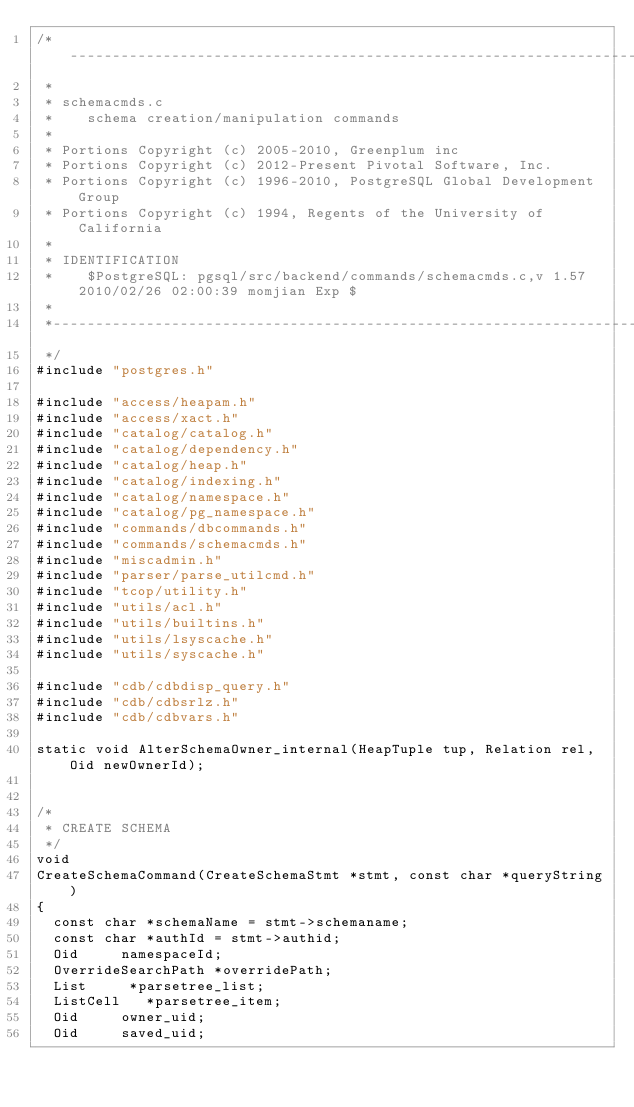Convert code to text. <code><loc_0><loc_0><loc_500><loc_500><_C_>/*-------------------------------------------------------------------------
 *
 * schemacmds.c
 *	  schema creation/manipulation commands
 *
 * Portions Copyright (c) 2005-2010, Greenplum inc
 * Portions Copyright (c) 2012-Present Pivotal Software, Inc.
 * Portions Copyright (c) 1996-2010, PostgreSQL Global Development Group
 * Portions Copyright (c) 1994, Regents of the University of California
 *
 * IDENTIFICATION
 *	  $PostgreSQL: pgsql/src/backend/commands/schemacmds.c,v 1.57 2010/02/26 02:00:39 momjian Exp $
 *
 *-------------------------------------------------------------------------
 */
#include "postgres.h"

#include "access/heapam.h"
#include "access/xact.h"
#include "catalog/catalog.h"
#include "catalog/dependency.h"
#include "catalog/heap.h"
#include "catalog/indexing.h"
#include "catalog/namespace.h"
#include "catalog/pg_namespace.h"
#include "commands/dbcommands.h"
#include "commands/schemacmds.h"
#include "miscadmin.h"
#include "parser/parse_utilcmd.h"
#include "tcop/utility.h"
#include "utils/acl.h"
#include "utils/builtins.h"
#include "utils/lsyscache.h"
#include "utils/syscache.h"

#include "cdb/cdbdisp_query.h"
#include "cdb/cdbsrlz.h"
#include "cdb/cdbvars.h"

static void AlterSchemaOwner_internal(HeapTuple tup, Relation rel, Oid newOwnerId);


/*
 * CREATE SCHEMA
 */
void
CreateSchemaCommand(CreateSchemaStmt *stmt, const char *queryString)
{
	const char *schemaName = stmt->schemaname;
	const char *authId = stmt->authid;
	Oid			namespaceId;
	OverrideSearchPath *overridePath;
	List	   *parsetree_list;
	ListCell   *parsetree_item;
	Oid			owner_uid;
	Oid			saved_uid;</code> 